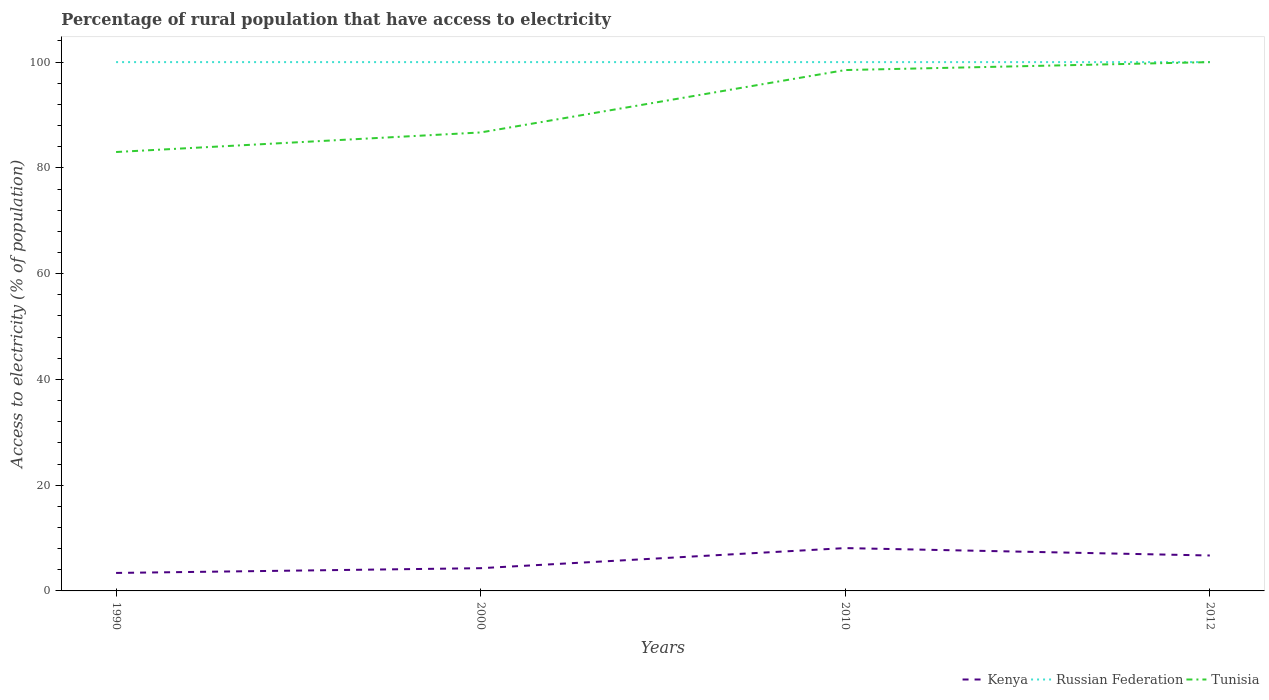How many different coloured lines are there?
Your response must be concise. 3. Does the line corresponding to Russian Federation intersect with the line corresponding to Kenya?
Make the answer very short. No. Is the number of lines equal to the number of legend labels?
Provide a short and direct response. Yes. In which year was the percentage of rural population that have access to electricity in Tunisia maximum?
Provide a succinct answer. 1990. What is the total percentage of rural population that have access to electricity in Kenya in the graph?
Your answer should be very brief. -3.3. What is the difference between the highest and the second highest percentage of rural population that have access to electricity in Kenya?
Your answer should be compact. 4.7. How many years are there in the graph?
Give a very brief answer. 4. What is the difference between two consecutive major ticks on the Y-axis?
Your answer should be very brief. 20. Are the values on the major ticks of Y-axis written in scientific E-notation?
Your answer should be compact. No. Does the graph contain any zero values?
Provide a short and direct response. No. How many legend labels are there?
Offer a terse response. 3. How are the legend labels stacked?
Provide a succinct answer. Horizontal. What is the title of the graph?
Keep it short and to the point. Percentage of rural population that have access to electricity. Does "New Caledonia" appear as one of the legend labels in the graph?
Keep it short and to the point. No. What is the label or title of the Y-axis?
Your answer should be very brief. Access to electricity (% of population). What is the Access to electricity (% of population) of Kenya in 1990?
Ensure brevity in your answer.  3.4. What is the Access to electricity (% of population) of Russian Federation in 1990?
Offer a terse response. 100. What is the Access to electricity (% of population) in Tunisia in 2000?
Give a very brief answer. 86.7. What is the Access to electricity (% of population) in Tunisia in 2010?
Provide a succinct answer. 98.5. Across all years, what is the maximum Access to electricity (% of population) of Kenya?
Give a very brief answer. 8.1. Across all years, what is the maximum Access to electricity (% of population) in Russian Federation?
Offer a very short reply. 100. Across all years, what is the minimum Access to electricity (% of population) of Kenya?
Your answer should be very brief. 3.4. Across all years, what is the minimum Access to electricity (% of population) of Tunisia?
Ensure brevity in your answer.  83. What is the total Access to electricity (% of population) in Kenya in the graph?
Your answer should be compact. 22.5. What is the total Access to electricity (% of population) of Tunisia in the graph?
Ensure brevity in your answer.  368.2. What is the difference between the Access to electricity (% of population) of Russian Federation in 1990 and that in 2000?
Make the answer very short. 0. What is the difference between the Access to electricity (% of population) in Russian Federation in 1990 and that in 2010?
Provide a succinct answer. 0. What is the difference between the Access to electricity (% of population) of Tunisia in 1990 and that in 2010?
Ensure brevity in your answer.  -15.5. What is the difference between the Access to electricity (% of population) in Kenya in 1990 and that in 2012?
Your response must be concise. -3.3. What is the difference between the Access to electricity (% of population) in Kenya in 2000 and that in 2010?
Keep it short and to the point. -3.8. What is the difference between the Access to electricity (% of population) of Tunisia in 2000 and that in 2010?
Provide a short and direct response. -11.8. What is the difference between the Access to electricity (% of population) in Kenya in 2000 and that in 2012?
Offer a terse response. -2.4. What is the difference between the Access to electricity (% of population) of Russian Federation in 2010 and that in 2012?
Your response must be concise. 0. What is the difference between the Access to electricity (% of population) in Kenya in 1990 and the Access to electricity (% of population) in Russian Federation in 2000?
Your response must be concise. -96.6. What is the difference between the Access to electricity (% of population) in Kenya in 1990 and the Access to electricity (% of population) in Tunisia in 2000?
Make the answer very short. -83.3. What is the difference between the Access to electricity (% of population) of Kenya in 1990 and the Access to electricity (% of population) of Russian Federation in 2010?
Your answer should be very brief. -96.6. What is the difference between the Access to electricity (% of population) of Kenya in 1990 and the Access to electricity (% of population) of Tunisia in 2010?
Your answer should be compact. -95.1. What is the difference between the Access to electricity (% of population) of Kenya in 1990 and the Access to electricity (% of population) of Russian Federation in 2012?
Give a very brief answer. -96.6. What is the difference between the Access to electricity (% of population) of Kenya in 1990 and the Access to electricity (% of population) of Tunisia in 2012?
Offer a very short reply. -96.6. What is the difference between the Access to electricity (% of population) in Kenya in 2000 and the Access to electricity (% of population) in Russian Federation in 2010?
Provide a short and direct response. -95.7. What is the difference between the Access to electricity (% of population) in Kenya in 2000 and the Access to electricity (% of population) in Tunisia in 2010?
Provide a short and direct response. -94.2. What is the difference between the Access to electricity (% of population) in Russian Federation in 2000 and the Access to electricity (% of population) in Tunisia in 2010?
Ensure brevity in your answer.  1.5. What is the difference between the Access to electricity (% of population) in Kenya in 2000 and the Access to electricity (% of population) in Russian Federation in 2012?
Make the answer very short. -95.7. What is the difference between the Access to electricity (% of population) in Kenya in 2000 and the Access to electricity (% of population) in Tunisia in 2012?
Make the answer very short. -95.7. What is the difference between the Access to electricity (% of population) in Russian Federation in 2000 and the Access to electricity (% of population) in Tunisia in 2012?
Give a very brief answer. 0. What is the difference between the Access to electricity (% of population) of Kenya in 2010 and the Access to electricity (% of population) of Russian Federation in 2012?
Give a very brief answer. -91.9. What is the difference between the Access to electricity (% of population) of Kenya in 2010 and the Access to electricity (% of population) of Tunisia in 2012?
Keep it short and to the point. -91.9. What is the difference between the Access to electricity (% of population) of Russian Federation in 2010 and the Access to electricity (% of population) of Tunisia in 2012?
Make the answer very short. 0. What is the average Access to electricity (% of population) in Kenya per year?
Give a very brief answer. 5.62. What is the average Access to electricity (% of population) in Russian Federation per year?
Your answer should be very brief. 100. What is the average Access to electricity (% of population) in Tunisia per year?
Your response must be concise. 92.05. In the year 1990, what is the difference between the Access to electricity (% of population) in Kenya and Access to electricity (% of population) in Russian Federation?
Provide a succinct answer. -96.6. In the year 1990, what is the difference between the Access to electricity (% of population) in Kenya and Access to electricity (% of population) in Tunisia?
Your answer should be compact. -79.6. In the year 2000, what is the difference between the Access to electricity (% of population) of Kenya and Access to electricity (% of population) of Russian Federation?
Ensure brevity in your answer.  -95.7. In the year 2000, what is the difference between the Access to electricity (% of population) in Kenya and Access to electricity (% of population) in Tunisia?
Provide a short and direct response. -82.4. In the year 2010, what is the difference between the Access to electricity (% of population) in Kenya and Access to electricity (% of population) in Russian Federation?
Keep it short and to the point. -91.9. In the year 2010, what is the difference between the Access to electricity (% of population) in Kenya and Access to electricity (% of population) in Tunisia?
Provide a succinct answer. -90.4. In the year 2010, what is the difference between the Access to electricity (% of population) in Russian Federation and Access to electricity (% of population) in Tunisia?
Your answer should be compact. 1.5. In the year 2012, what is the difference between the Access to electricity (% of population) in Kenya and Access to electricity (% of population) in Russian Federation?
Your response must be concise. -93.3. In the year 2012, what is the difference between the Access to electricity (% of population) in Kenya and Access to electricity (% of population) in Tunisia?
Ensure brevity in your answer.  -93.3. What is the ratio of the Access to electricity (% of population) in Kenya in 1990 to that in 2000?
Your answer should be compact. 0.79. What is the ratio of the Access to electricity (% of population) in Tunisia in 1990 to that in 2000?
Offer a very short reply. 0.96. What is the ratio of the Access to electricity (% of population) of Kenya in 1990 to that in 2010?
Your answer should be very brief. 0.42. What is the ratio of the Access to electricity (% of population) in Tunisia in 1990 to that in 2010?
Provide a short and direct response. 0.84. What is the ratio of the Access to electricity (% of population) of Kenya in 1990 to that in 2012?
Your answer should be very brief. 0.51. What is the ratio of the Access to electricity (% of population) of Russian Federation in 1990 to that in 2012?
Offer a very short reply. 1. What is the ratio of the Access to electricity (% of population) of Tunisia in 1990 to that in 2012?
Keep it short and to the point. 0.83. What is the ratio of the Access to electricity (% of population) of Kenya in 2000 to that in 2010?
Offer a terse response. 0.53. What is the ratio of the Access to electricity (% of population) of Russian Federation in 2000 to that in 2010?
Your response must be concise. 1. What is the ratio of the Access to electricity (% of population) in Tunisia in 2000 to that in 2010?
Make the answer very short. 0.88. What is the ratio of the Access to electricity (% of population) of Kenya in 2000 to that in 2012?
Provide a succinct answer. 0.64. What is the ratio of the Access to electricity (% of population) in Russian Federation in 2000 to that in 2012?
Your answer should be very brief. 1. What is the ratio of the Access to electricity (% of population) of Tunisia in 2000 to that in 2012?
Your response must be concise. 0.87. What is the ratio of the Access to electricity (% of population) of Kenya in 2010 to that in 2012?
Give a very brief answer. 1.21. What is the ratio of the Access to electricity (% of population) in Russian Federation in 2010 to that in 2012?
Make the answer very short. 1. What is the difference between the highest and the second highest Access to electricity (% of population) in Kenya?
Provide a short and direct response. 1.4. What is the difference between the highest and the second highest Access to electricity (% of population) in Russian Federation?
Make the answer very short. 0. What is the difference between the highest and the second highest Access to electricity (% of population) of Tunisia?
Your answer should be very brief. 1.5. What is the difference between the highest and the lowest Access to electricity (% of population) in Russian Federation?
Provide a short and direct response. 0. What is the difference between the highest and the lowest Access to electricity (% of population) of Tunisia?
Offer a terse response. 17. 